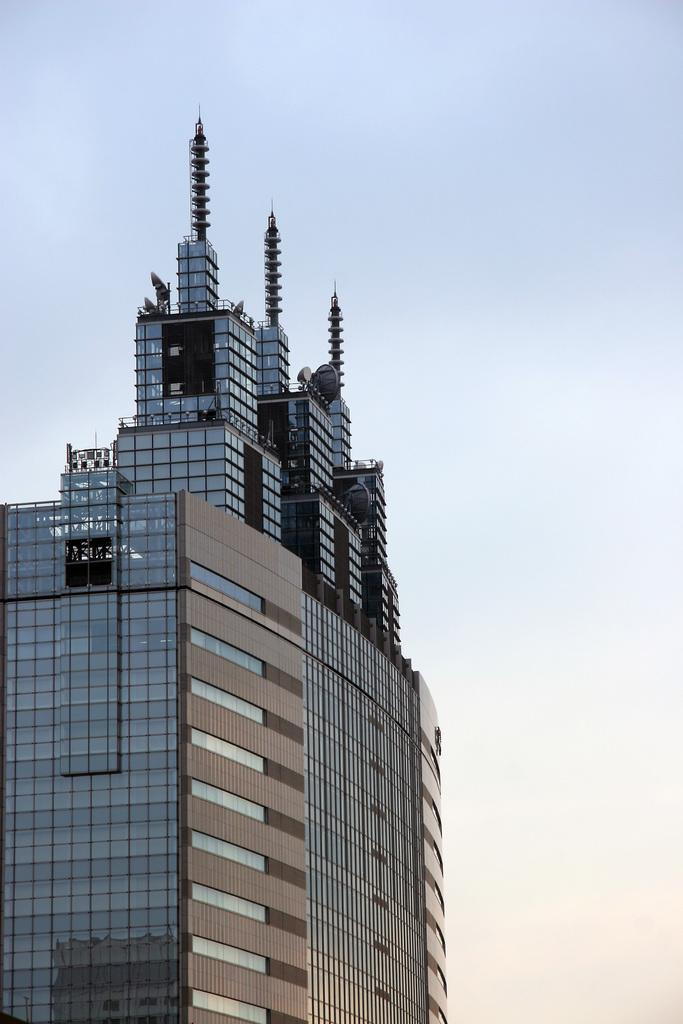What type of structure is present in the image? There is a building in the image. What part of the natural environment is visible in the image? The sky is visible in the image. Where is the mailbox located in the image? There is no mailbox present in the image. What type of mountain range can be seen in the background of the image? There is no mountain range visible in the image; it only features a building and the sky. 